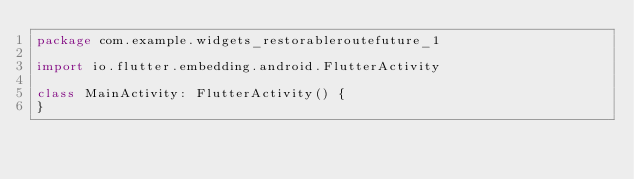Convert code to text. <code><loc_0><loc_0><loc_500><loc_500><_Kotlin_>package com.example.widgets_restorableroutefuture_1

import io.flutter.embedding.android.FlutterActivity

class MainActivity: FlutterActivity() {
}
</code> 